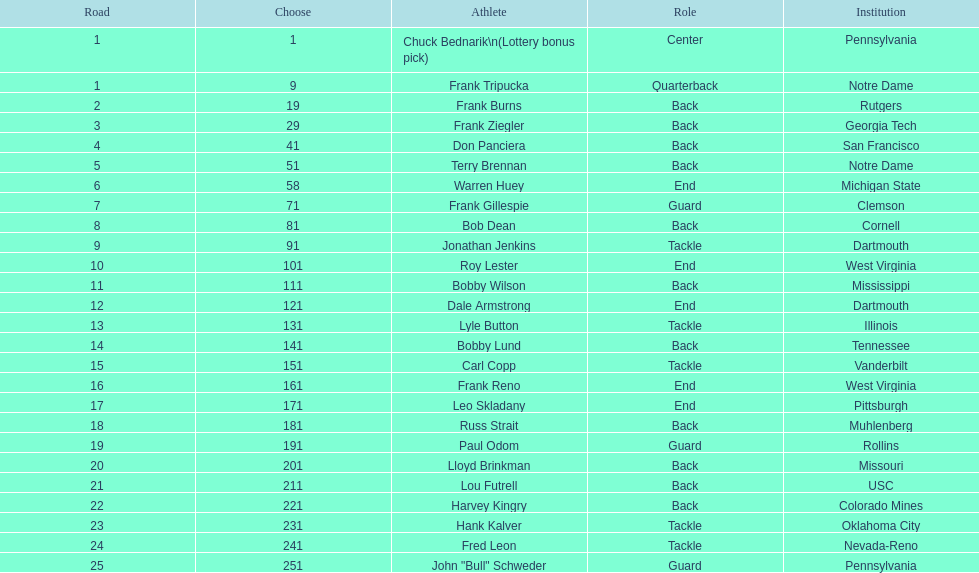Give me the full table as a dictionary. {'header': ['Road', 'Choose', 'Athlete', 'Role', 'Institution'], 'rows': [['1', '1', 'Chuck Bednarik\\n(Lottery bonus pick)', 'Center', 'Pennsylvania'], ['1', '9', 'Frank Tripucka', 'Quarterback', 'Notre Dame'], ['2', '19', 'Frank Burns', 'Back', 'Rutgers'], ['3', '29', 'Frank Ziegler', 'Back', 'Georgia Tech'], ['4', '41', 'Don Panciera', 'Back', 'San Francisco'], ['5', '51', 'Terry Brennan', 'Back', 'Notre Dame'], ['6', '58', 'Warren Huey', 'End', 'Michigan State'], ['7', '71', 'Frank Gillespie', 'Guard', 'Clemson'], ['8', '81', 'Bob Dean', 'Back', 'Cornell'], ['9', '91', 'Jonathan Jenkins', 'Tackle', 'Dartmouth'], ['10', '101', 'Roy Lester', 'End', 'West Virginia'], ['11', '111', 'Bobby Wilson', 'Back', 'Mississippi'], ['12', '121', 'Dale Armstrong', 'End', 'Dartmouth'], ['13', '131', 'Lyle Button', 'Tackle', 'Illinois'], ['14', '141', 'Bobby Lund', 'Back', 'Tennessee'], ['15', '151', 'Carl Copp', 'Tackle', 'Vanderbilt'], ['16', '161', 'Frank Reno', 'End', 'West Virginia'], ['17', '171', 'Leo Skladany', 'End', 'Pittsburgh'], ['18', '181', 'Russ Strait', 'Back', 'Muhlenberg'], ['19', '191', 'Paul Odom', 'Guard', 'Rollins'], ['20', '201', 'Lloyd Brinkman', 'Back', 'Missouri'], ['21', '211', 'Lou Futrell', 'Back', 'USC'], ['22', '221', 'Harvey Kingry', 'Back', 'Colorado Mines'], ['23', '231', 'Hank Kalver', 'Tackle', 'Oklahoma City'], ['24', '241', 'Fred Leon', 'Tackle', 'Nevada-Reno'], ['25', '251', 'John "Bull" Schweder', 'Guard', 'Pennsylvania']]} Who was the player that the team drafted after bob dean? Jonathan Jenkins. 